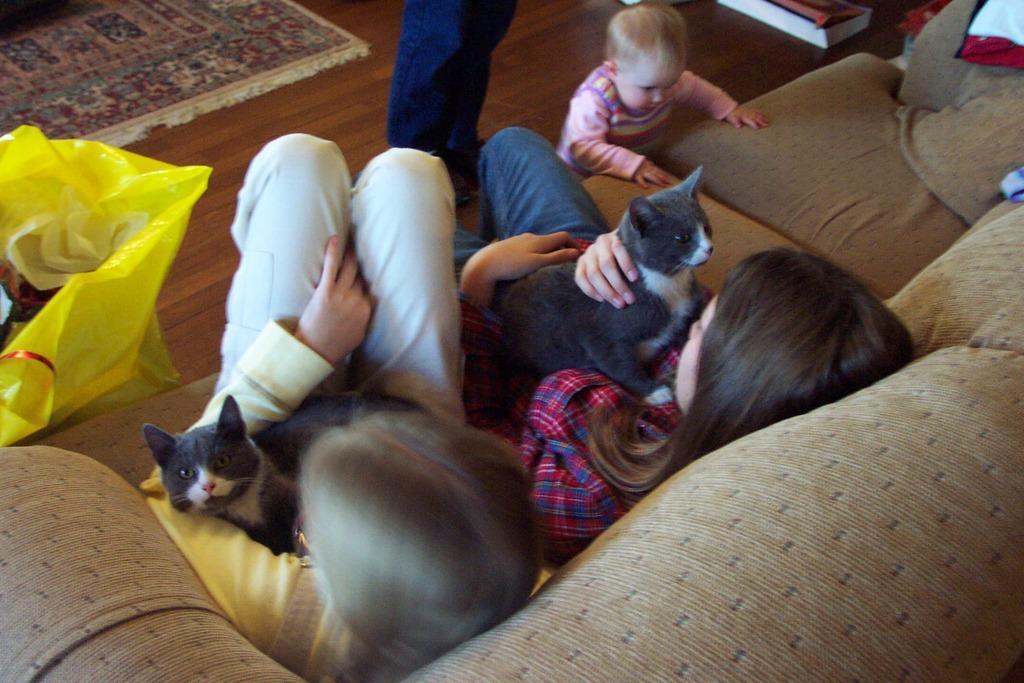Could you give a brief overview of what you see in this image? There are two kids sitting on a sofa and holding a cat. There is a cover on the left side of this image, and there is one person standing at the top of this image, and there is one kid standing on the right side to him. 